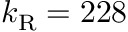<formula> <loc_0><loc_0><loc_500><loc_500>k _ { R } = 2 2 8</formula> 